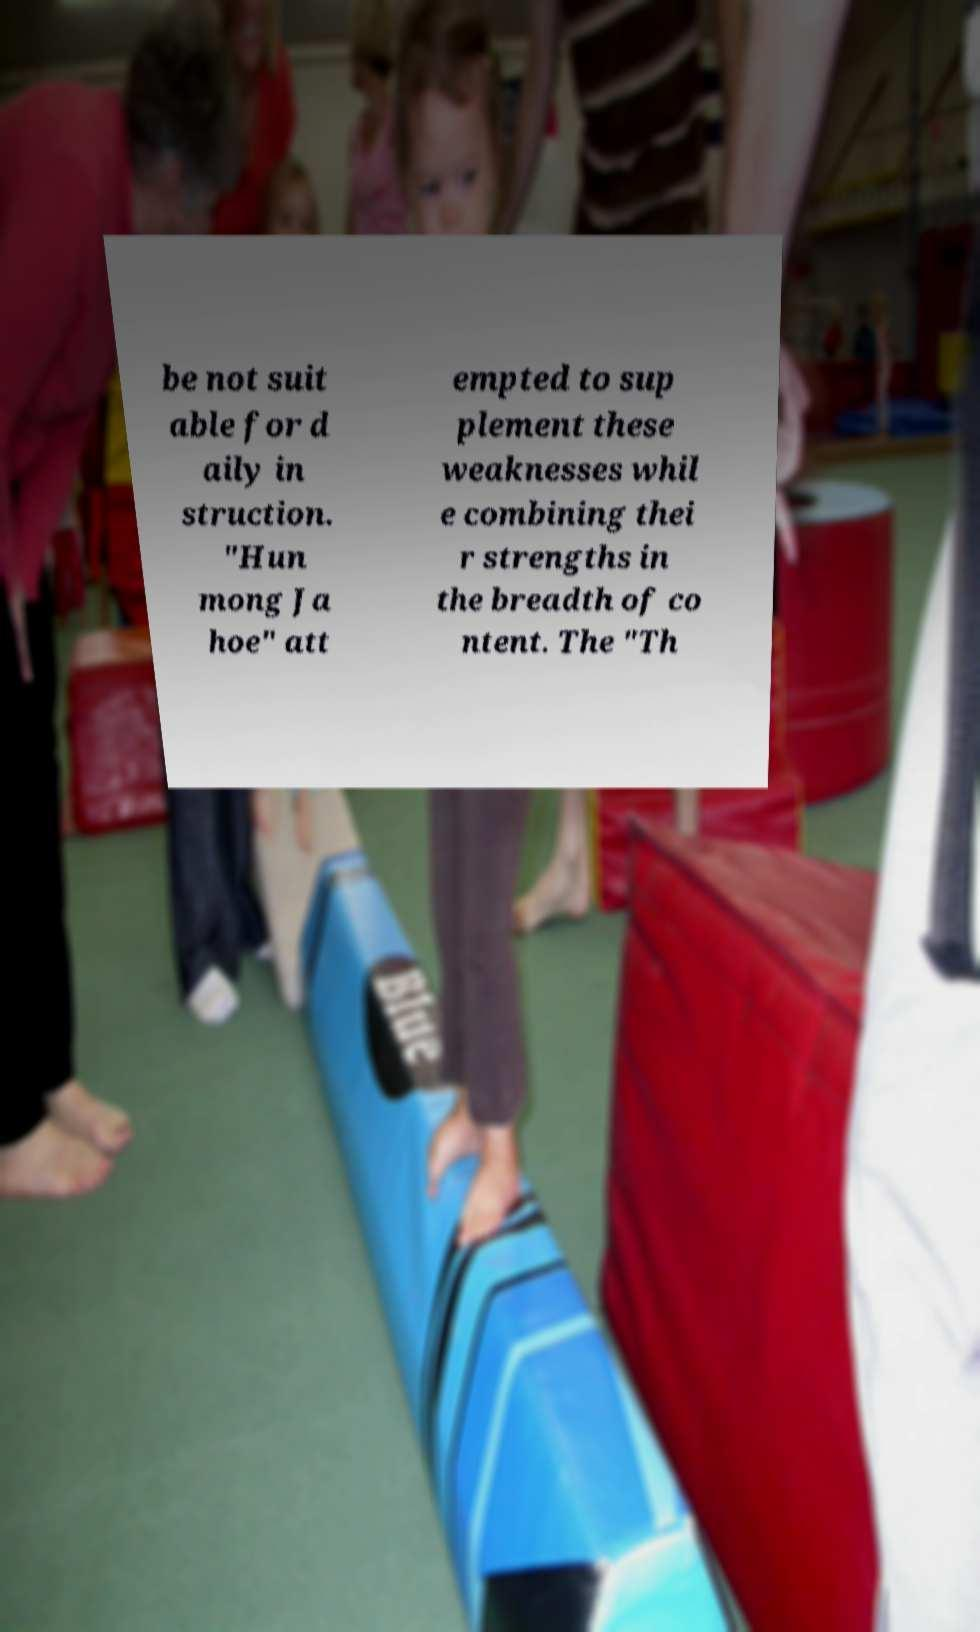Can you accurately transcribe the text from the provided image for me? be not suit able for d aily in struction. "Hun mong Ja hoe" att empted to sup plement these weaknesses whil e combining thei r strengths in the breadth of co ntent. The "Th 